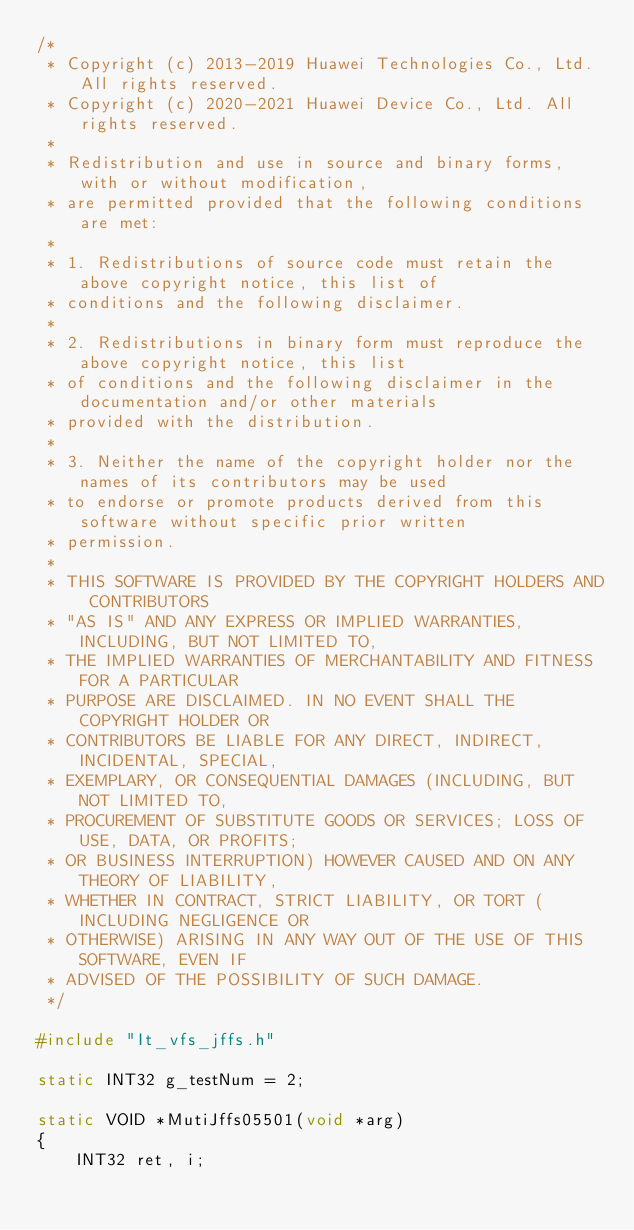Convert code to text. <code><loc_0><loc_0><loc_500><loc_500><_C++_>/*
 * Copyright (c) 2013-2019 Huawei Technologies Co., Ltd. All rights reserved.
 * Copyright (c) 2020-2021 Huawei Device Co., Ltd. All rights reserved.
 *
 * Redistribution and use in source and binary forms, with or without modification,
 * are permitted provided that the following conditions are met:
 *
 * 1. Redistributions of source code must retain the above copyright notice, this list of
 * conditions and the following disclaimer.
 *
 * 2. Redistributions in binary form must reproduce the above copyright notice, this list
 * of conditions and the following disclaimer in the documentation and/or other materials
 * provided with the distribution.
 *
 * 3. Neither the name of the copyright holder nor the names of its contributors may be used
 * to endorse or promote products derived from this software without specific prior written
 * permission.
 *
 * THIS SOFTWARE IS PROVIDED BY THE COPYRIGHT HOLDERS AND CONTRIBUTORS
 * "AS IS" AND ANY EXPRESS OR IMPLIED WARRANTIES, INCLUDING, BUT NOT LIMITED TO,
 * THE IMPLIED WARRANTIES OF MERCHANTABILITY AND FITNESS FOR A PARTICULAR
 * PURPOSE ARE DISCLAIMED. IN NO EVENT SHALL THE COPYRIGHT HOLDER OR
 * CONTRIBUTORS BE LIABLE FOR ANY DIRECT, INDIRECT, INCIDENTAL, SPECIAL,
 * EXEMPLARY, OR CONSEQUENTIAL DAMAGES (INCLUDING, BUT NOT LIMITED TO,
 * PROCUREMENT OF SUBSTITUTE GOODS OR SERVICES; LOSS OF USE, DATA, OR PROFITS;
 * OR BUSINESS INTERRUPTION) HOWEVER CAUSED AND ON ANY THEORY OF LIABILITY,
 * WHETHER IN CONTRACT, STRICT LIABILITY, OR TORT (INCLUDING NEGLIGENCE OR
 * OTHERWISE) ARISING IN ANY WAY OUT OF THE USE OF THIS SOFTWARE, EVEN IF
 * ADVISED OF THE POSSIBILITY OF SUCH DAMAGE.
 */

#include "It_vfs_jffs.h"

static INT32 g_testNum = 2;

static VOID *MutiJffs05501(void *arg)
{
    INT32 ret, i;</code> 